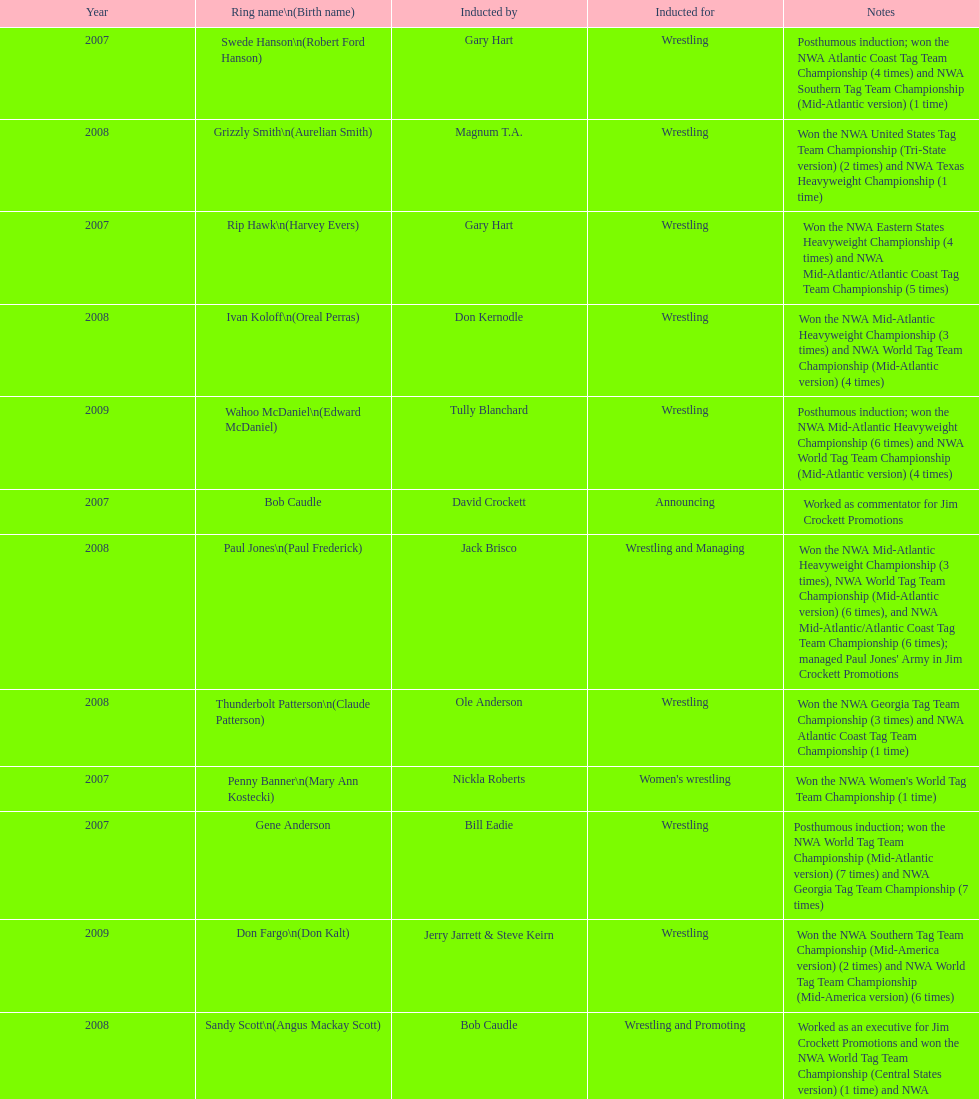Who was enrolled after royal? Lance Russell. Parse the table in full. {'header': ['Year', 'Ring name\\n(Birth name)', 'Inducted by', 'Inducted for', 'Notes'], 'rows': [['2007', 'Swede Hanson\\n(Robert Ford Hanson)', 'Gary Hart', 'Wrestling', 'Posthumous induction; won the NWA Atlantic Coast Tag Team Championship (4 times) and NWA Southern Tag Team Championship (Mid-Atlantic version) (1 time)'], ['2008', 'Grizzly Smith\\n(Aurelian Smith)', 'Magnum T.A.', 'Wrestling', 'Won the NWA United States Tag Team Championship (Tri-State version) (2 times) and NWA Texas Heavyweight Championship (1 time)'], ['2007', 'Rip Hawk\\n(Harvey Evers)', 'Gary Hart', 'Wrestling', 'Won the NWA Eastern States Heavyweight Championship (4 times) and NWA Mid-Atlantic/Atlantic Coast Tag Team Championship (5 times)'], ['2008', 'Ivan Koloff\\n(Oreal Perras)', 'Don Kernodle', 'Wrestling', 'Won the NWA Mid-Atlantic Heavyweight Championship (3 times) and NWA World Tag Team Championship (Mid-Atlantic version) (4 times)'], ['2009', 'Wahoo McDaniel\\n(Edward McDaniel)', 'Tully Blanchard', 'Wrestling', 'Posthumous induction; won the NWA Mid-Atlantic Heavyweight Championship (6 times) and NWA World Tag Team Championship (Mid-Atlantic version) (4 times)'], ['2007', 'Bob Caudle', 'David Crockett', 'Announcing', 'Worked as commentator for Jim Crockett Promotions'], ['2008', 'Paul Jones\\n(Paul Frederick)', 'Jack Brisco', 'Wrestling and Managing', "Won the NWA Mid-Atlantic Heavyweight Championship (3 times), NWA World Tag Team Championship (Mid-Atlantic version) (6 times), and NWA Mid-Atlantic/Atlantic Coast Tag Team Championship (6 times); managed Paul Jones' Army in Jim Crockett Promotions"], ['2008', 'Thunderbolt Patterson\\n(Claude Patterson)', 'Ole Anderson', 'Wrestling', 'Won the NWA Georgia Tag Team Championship (3 times) and NWA Atlantic Coast Tag Team Championship (1 time)'], ['2007', 'Penny Banner\\n(Mary Ann Kostecki)', 'Nickla Roberts', "Women's wrestling", "Won the NWA Women's World Tag Team Championship (1 time)"], ['2007', 'Gene Anderson', 'Bill Eadie', 'Wrestling', 'Posthumous induction; won the NWA World Tag Team Championship (Mid-Atlantic version) (7 times) and NWA Georgia Tag Team Championship (7 times)'], ['2009', 'Don Fargo\\n(Don Kalt)', 'Jerry Jarrett & Steve Keirn', 'Wrestling', 'Won the NWA Southern Tag Team Championship (Mid-America version) (2 times) and NWA World Tag Team Championship (Mid-America version) (6 times)'], ['2008', 'Sandy Scott\\n(Angus Mackay Scott)', 'Bob Caudle', 'Wrestling and Promoting', 'Worked as an executive for Jim Crockett Promotions and won the NWA World Tag Team Championship (Central States version) (1 time) and NWA Southern Tag Team Championship (Mid-Atlantic version) (3 times)'], ['2009', 'Gary Hart\\n(Gary Williams)', 'Sir Oliver Humperdink', 'Managing and Promoting', 'Posthumous induction; worked as a booker in World Class Championship Wrestling and managed several wrestlers in Mid-Atlantic Championship Wrestling'], ['2007', 'George Scott', 'Tommy Young', 'Wrestling and Promoting', 'Won the NWA Southern Tag Team Championship (Mid-Atlantic version) (2 times) and worked as booker for Jim Crockett Promotions'], ['2009', 'Blackjack Mulligan\\n(Robert Windham)', 'Ric Flair', 'Wrestling', 'Won the NWA Texas Heavyweight Championship (1 time) and NWA World Tag Team Championship (Mid-Atlantic version) (1 time)'], ['2009', 'Lance Russell', 'Dave Brown', 'Announcing', 'Worked as commentator for wrestling events in the Memphis area'], ['2009', 'Sonny Fargo\\n(Jack Lewis Faggart)', 'Jerry Jarrett & Steve Keirn', 'Wrestling', 'Posthumous induction; won the NWA Southern Tag Team Championship (Mid-America version) (3 times)'], ['2007', 'Ole Anderson\\n(Alan Rogowski)', 'Bill Eadie', 'Wrestling', 'Won the NWA Mid-Atlantic/Atlantic Coast Tag Team Championship (7 times) and NWA World Tag Team Championship (Mid-Atlantic version) (8 times)'], ['2009', 'Jackie Fargo\\n(Henry Faggart)', 'Jerry Jarrett & Steve Keirn', 'Wrestling', 'Won the NWA World Tag Team Championship (Mid-America version) (10 times) and NWA Southern Tag Team Championship (Mid-America version) (22 times)'], ['2009', 'Nelson Royal', 'Brad Anderson, Tommy Angel & David Isley', 'Wrestling', 'Won the NWA Atlantic Coast Tag Team Championship (2 times)'], ['2008', 'Johnny Weaver\\n(Kenneth Eugene Weaver)', 'Rip Hawk', 'Wrestling', 'Posthumous induction; won the NWA Atlantic Coast/Mid-Atlantic Tag Team Championship (8 times) and NWA Southern Tag Team Championship (Mid-Atlantic version) (6 times)'], ['2008', 'Buddy Roberts\\n(Dale Hey)', 'Jimmy Garvin and Michael Hayes', 'Wrestling', 'Won the NWA World Six-Man Tag Team Championship (Texas version) / WCWA World Six-Man Tag Team Championship (6 times) and NWA Mid-Atlantic Tag Team Championship (1 time)']]} 